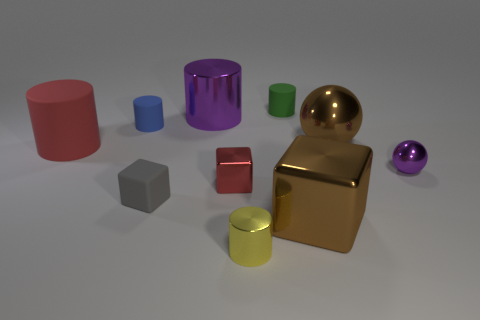There is a green thing that is the same material as the big red cylinder; what is its shape?
Offer a terse response. Cylinder. There is a small cylinder to the left of the rubber object that is in front of the large red cylinder; what number of big brown shiny objects are on the left side of it?
Offer a very short reply. 0. What shape is the tiny rubber thing that is in front of the green cylinder and behind the red cube?
Your answer should be very brief. Cylinder. Is the number of brown metallic spheres that are in front of the small purple metal sphere less than the number of big yellow shiny cylinders?
Provide a short and direct response. No. What number of tiny things are green things or metal balls?
Make the answer very short. 2. What size is the purple cylinder?
Make the answer very short. Large. Are there any other things that have the same material as the yellow thing?
Your answer should be compact. Yes. There is a small green rubber cylinder; what number of cubes are right of it?
Your response must be concise. 1. There is a green thing that is the same shape as the blue rubber object; what size is it?
Provide a succinct answer. Small. There is a shiny thing that is both to the left of the brown metallic cube and behind the small red thing; how big is it?
Make the answer very short. Large. 